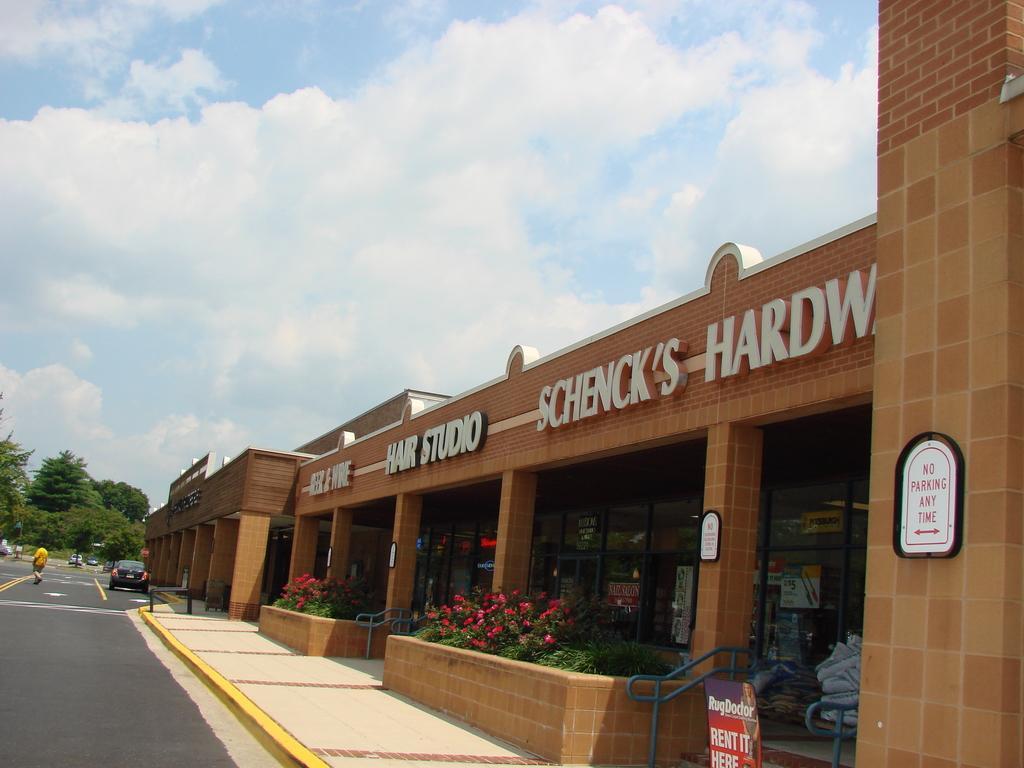Please provide a concise description of this image. In this picture we can see clouds in the sky. We can see trees, pillars, letter boards, flower plants, railings, boards and few objects. We can see vehicles on the road. We can see a person crossing the road. In the bottom right corner of the picture we can see a board with some information. 